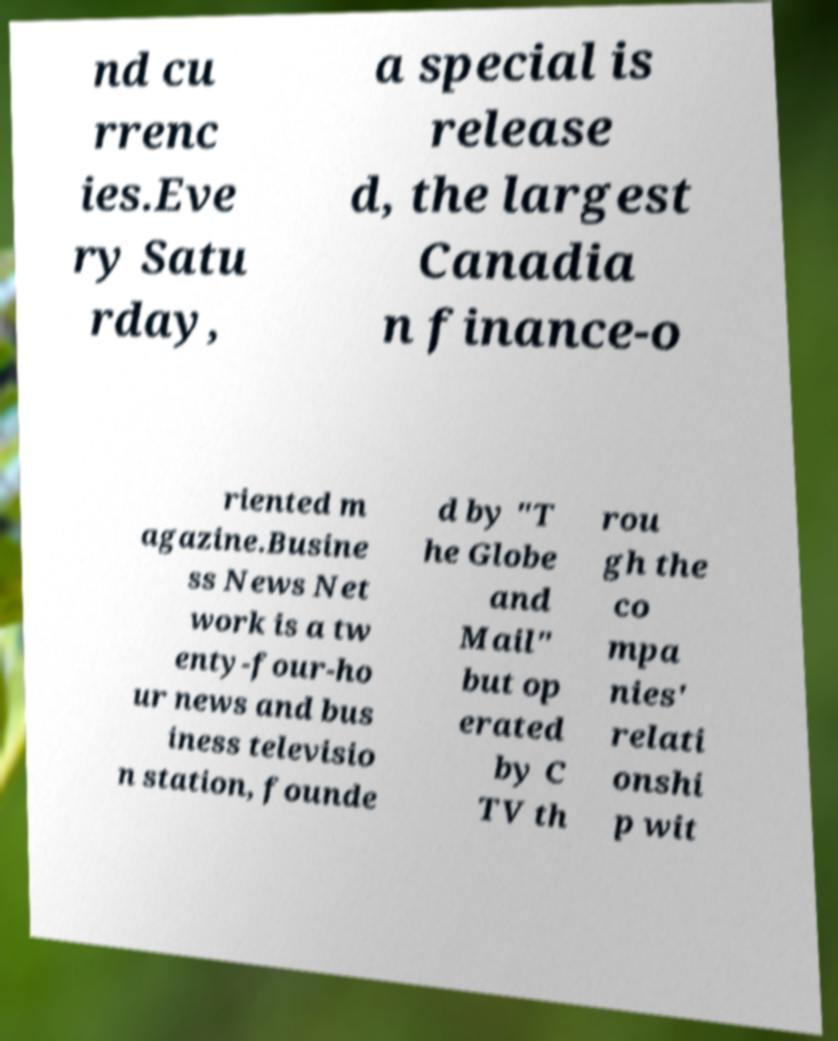Please identify and transcribe the text found in this image. nd cu rrenc ies.Eve ry Satu rday, a special is release d, the largest Canadia n finance-o riented m agazine.Busine ss News Net work is a tw enty-four-ho ur news and bus iness televisio n station, founde d by "T he Globe and Mail" but op erated by C TV th rou gh the co mpa nies' relati onshi p wit 